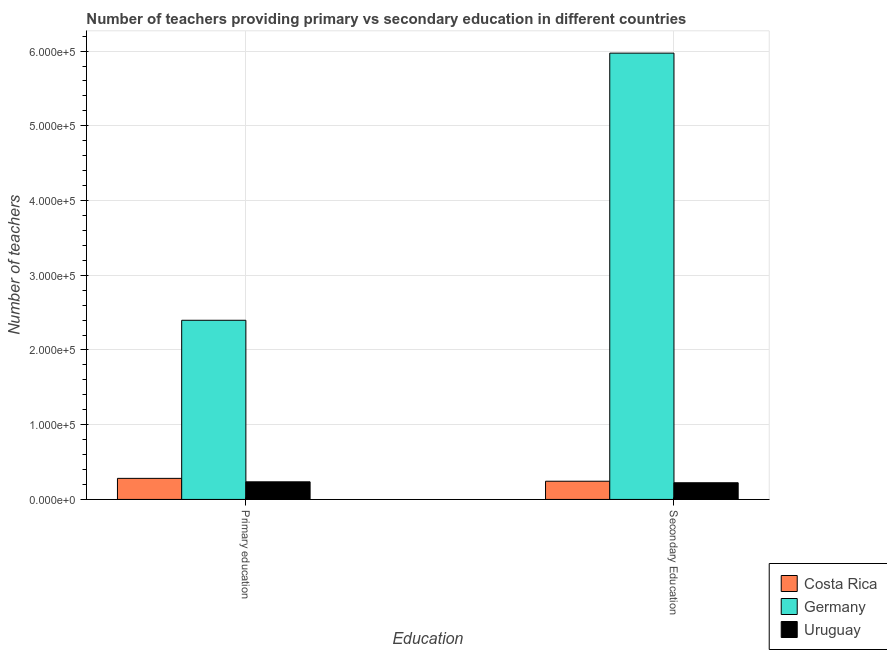How many different coloured bars are there?
Offer a terse response. 3. How many bars are there on the 1st tick from the right?
Your answer should be very brief. 3. What is the label of the 2nd group of bars from the left?
Give a very brief answer. Secondary Education. What is the number of primary teachers in Costa Rica?
Your answer should be compact. 2.82e+04. Across all countries, what is the maximum number of primary teachers?
Offer a terse response. 2.40e+05. Across all countries, what is the minimum number of secondary teachers?
Offer a very short reply. 2.23e+04. In which country was the number of primary teachers minimum?
Your answer should be compact. Uruguay. What is the total number of primary teachers in the graph?
Your response must be concise. 2.92e+05. What is the difference between the number of secondary teachers in Costa Rica and that in Germany?
Provide a short and direct response. -5.73e+05. What is the difference between the number of secondary teachers in Uruguay and the number of primary teachers in Costa Rica?
Offer a very short reply. -5871. What is the average number of primary teachers per country?
Offer a very short reply. 9.72e+04. What is the difference between the number of secondary teachers and number of primary teachers in Uruguay?
Provide a short and direct response. -1240. What is the ratio of the number of secondary teachers in Germany to that in Uruguay?
Offer a terse response. 26.77. Is the number of secondary teachers in Uruguay less than that in Costa Rica?
Make the answer very short. Yes. What does the 1st bar from the right in Primary education represents?
Make the answer very short. Uruguay. How many bars are there?
Make the answer very short. 6. Are all the bars in the graph horizontal?
Make the answer very short. No. How many countries are there in the graph?
Provide a succinct answer. 3. Are the values on the major ticks of Y-axis written in scientific E-notation?
Give a very brief answer. Yes. Does the graph contain grids?
Provide a succinct answer. Yes. Where does the legend appear in the graph?
Give a very brief answer. Bottom right. How many legend labels are there?
Your answer should be compact. 3. How are the legend labels stacked?
Offer a terse response. Vertical. What is the title of the graph?
Provide a succinct answer. Number of teachers providing primary vs secondary education in different countries. Does "New Caledonia" appear as one of the legend labels in the graph?
Your answer should be very brief. No. What is the label or title of the X-axis?
Keep it short and to the point. Education. What is the label or title of the Y-axis?
Your answer should be compact. Number of teachers. What is the Number of teachers of Costa Rica in Primary education?
Your answer should be compact. 2.82e+04. What is the Number of teachers of Germany in Primary education?
Keep it short and to the point. 2.40e+05. What is the Number of teachers of Uruguay in Primary education?
Make the answer very short. 2.36e+04. What is the Number of teachers of Costa Rica in Secondary Education?
Give a very brief answer. 2.43e+04. What is the Number of teachers in Germany in Secondary Education?
Keep it short and to the point. 5.97e+05. What is the Number of teachers in Uruguay in Secondary Education?
Give a very brief answer. 2.23e+04. Across all Education, what is the maximum Number of teachers of Costa Rica?
Provide a short and direct response. 2.82e+04. Across all Education, what is the maximum Number of teachers in Germany?
Offer a terse response. 5.97e+05. Across all Education, what is the maximum Number of teachers of Uruguay?
Make the answer very short. 2.36e+04. Across all Education, what is the minimum Number of teachers of Costa Rica?
Your response must be concise. 2.43e+04. Across all Education, what is the minimum Number of teachers in Germany?
Offer a very short reply. 2.40e+05. Across all Education, what is the minimum Number of teachers in Uruguay?
Ensure brevity in your answer.  2.23e+04. What is the total Number of teachers in Costa Rica in the graph?
Keep it short and to the point. 5.25e+04. What is the total Number of teachers of Germany in the graph?
Offer a very short reply. 8.37e+05. What is the total Number of teachers in Uruguay in the graph?
Your answer should be very brief. 4.59e+04. What is the difference between the Number of teachers in Costa Rica in Primary education and that in Secondary Education?
Provide a succinct answer. 3839. What is the difference between the Number of teachers in Germany in Primary education and that in Secondary Education?
Your response must be concise. -3.58e+05. What is the difference between the Number of teachers in Uruguay in Primary education and that in Secondary Education?
Keep it short and to the point. 1240. What is the difference between the Number of teachers in Costa Rica in Primary education and the Number of teachers in Germany in Secondary Education?
Provide a short and direct response. -5.69e+05. What is the difference between the Number of teachers of Costa Rica in Primary education and the Number of teachers of Uruguay in Secondary Education?
Give a very brief answer. 5871. What is the difference between the Number of teachers in Germany in Primary education and the Number of teachers in Uruguay in Secondary Education?
Make the answer very short. 2.17e+05. What is the average Number of teachers in Costa Rica per Education?
Offer a very short reply. 2.63e+04. What is the average Number of teachers in Germany per Education?
Offer a terse response. 4.19e+05. What is the average Number of teachers in Uruguay per Education?
Give a very brief answer. 2.29e+04. What is the difference between the Number of teachers in Costa Rica and Number of teachers in Germany in Primary education?
Offer a terse response. -2.12e+05. What is the difference between the Number of teachers in Costa Rica and Number of teachers in Uruguay in Primary education?
Keep it short and to the point. 4631. What is the difference between the Number of teachers in Germany and Number of teachers in Uruguay in Primary education?
Keep it short and to the point. 2.16e+05. What is the difference between the Number of teachers in Costa Rica and Number of teachers in Germany in Secondary Education?
Give a very brief answer. -5.73e+05. What is the difference between the Number of teachers in Costa Rica and Number of teachers in Uruguay in Secondary Education?
Make the answer very short. 2032. What is the difference between the Number of teachers of Germany and Number of teachers of Uruguay in Secondary Education?
Offer a very short reply. 5.75e+05. What is the ratio of the Number of teachers in Costa Rica in Primary education to that in Secondary Education?
Your response must be concise. 1.16. What is the ratio of the Number of teachers in Germany in Primary education to that in Secondary Education?
Offer a very short reply. 0.4. What is the ratio of the Number of teachers of Uruguay in Primary education to that in Secondary Education?
Offer a very short reply. 1.06. What is the difference between the highest and the second highest Number of teachers of Costa Rica?
Your answer should be very brief. 3839. What is the difference between the highest and the second highest Number of teachers in Germany?
Offer a very short reply. 3.58e+05. What is the difference between the highest and the second highest Number of teachers in Uruguay?
Ensure brevity in your answer.  1240. What is the difference between the highest and the lowest Number of teachers in Costa Rica?
Keep it short and to the point. 3839. What is the difference between the highest and the lowest Number of teachers in Germany?
Give a very brief answer. 3.58e+05. What is the difference between the highest and the lowest Number of teachers in Uruguay?
Provide a succinct answer. 1240. 